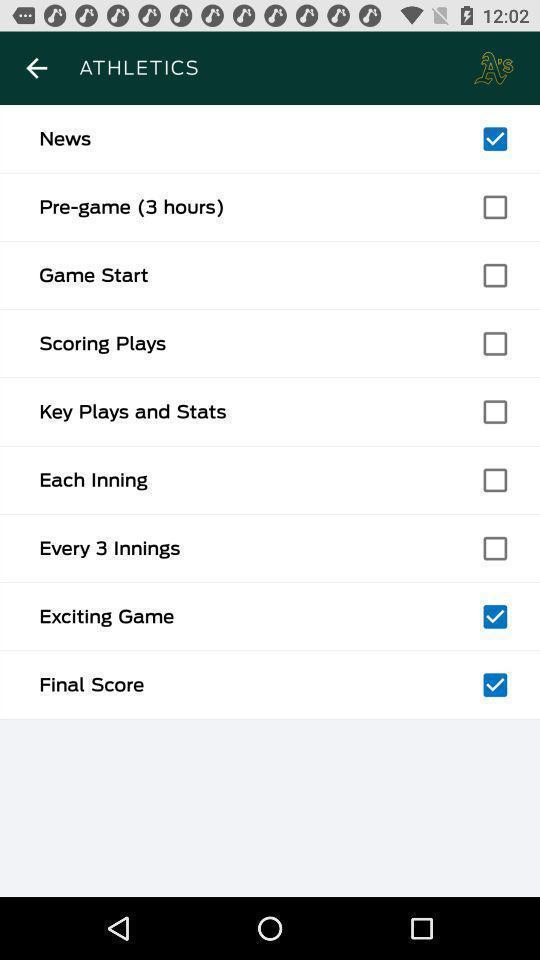Describe this image in words. Page showing multiple options in athletics. 